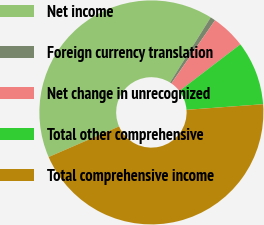Convert chart. <chart><loc_0><loc_0><loc_500><loc_500><pie_chart><fcel>Net income<fcel>Foreign currency translation<fcel>Net change in unrecognized<fcel>Total other comprehensive<fcel>Total comprehensive income<nl><fcel>40.4%<fcel>0.74%<fcel>4.98%<fcel>9.23%<fcel>44.65%<nl></chart> 